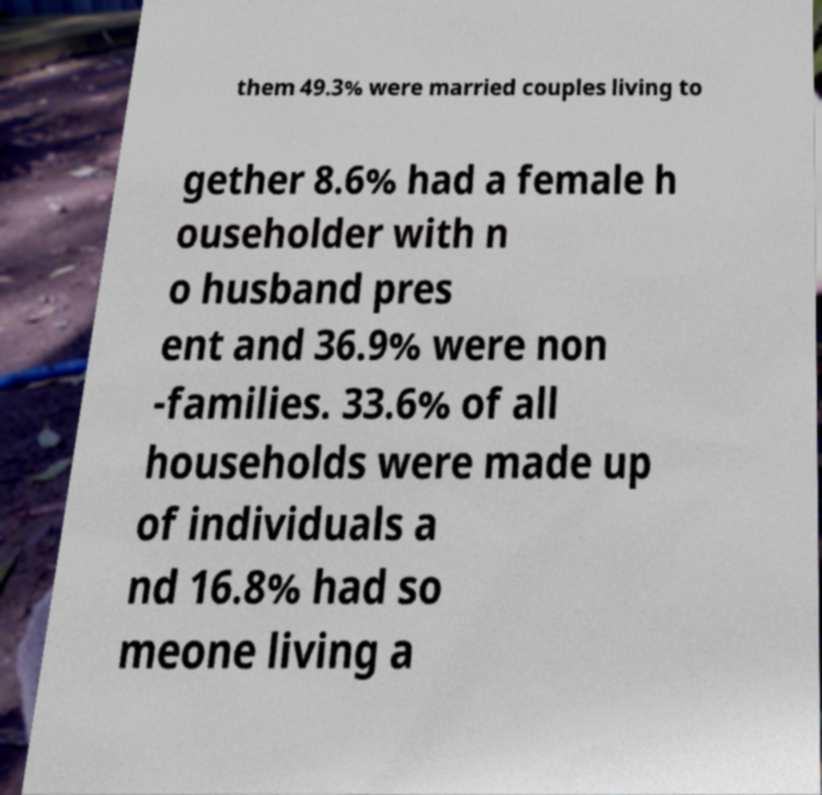Can you read and provide the text displayed in the image?This photo seems to have some interesting text. Can you extract and type it out for me? them 49.3% were married couples living to gether 8.6% had a female h ouseholder with n o husband pres ent and 36.9% were non -families. 33.6% of all households were made up of individuals a nd 16.8% had so meone living a 